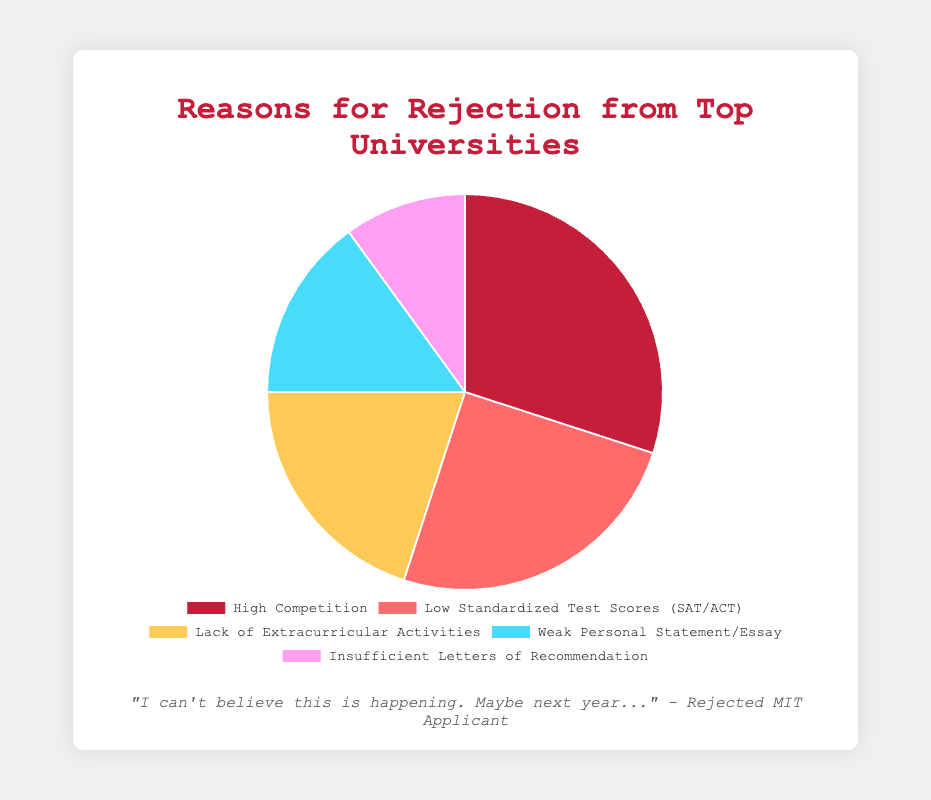What is the most common reason for rejection from top universities? By examining the pie chart, "High Competition" is the segment with the largest percentage.
Answer: High Competition Which reason accounts for the smallest percentage of rejections? The smallest slice of the pie represents "Insufficient Letters of Recommendation" at 10%.
Answer: Insufficient Letters of Recommendation How much larger is the percentage for "Low Standardized Test Scores (SAT/ACT)" compared to "Weak Personal Statement/Essay"? "Low Standardized Test Scores (SAT/ACT)" is 25%, and "Weak Personal Statement/Essay" is 15%. The difference is 10 percentage points.
Answer: 10 percentage points What is the combined percentage of rejections due to "Lack of Extracurricular Activities" and "Weak Personal Statement/Essay"? Summing the percentages for "Lack of Extracurricular Activities" (20%) and "Weak Personal Statement/Essay" (15%) gives 35%.
Answer: 35% Are there more rejections due to "Low Standardized Test Scores (SAT/ACT)" or "Lack of Extracurricular Activities"? The slice for "Low Standardized Test Scores (SAT/ACT)" (25%) is larger than the slice for "Lack of Extracurricular Activities" (20%).
Answer: Low Standardized Test Scores (SAT/ACT) What proportion of rejections is attributed to factors other than "High Competition"? Subtracting the "High Competition" percentage (30%) from 100% gives 70%, indicating the proportion for other factors.
Answer: 70% If you combined the percentages for "Insufficient Letters of Recommendation" and "Weak Personal Statement/Essay", would it exceed the percentage for "High Competition"? "Insufficient Letters of Recommendation" is 10% and "Weak Personal Statement/Essay" is 15%, totaling 25%, which is less than "High Competition" at 30%.
Answer: No Which reason has a lower percentage than "Lack of Extracurricular Activities" but higher than "Insufficient Letters of Recommendation"? The percentages are 20% for "Lack of Extracurricular Activities" and 10% for "Insufficient Letters of Recommendation", so "Weak Personal Statement/Essay" with 15% falls between them.
Answer: Weak Personal Statement/Essay What is the visual color used for the "High Competition" segment? The "High Competition" segment is represented by a red color on the pie chart.
Answer: Red How do the total percentages of "Low Standardized Test Scores (SAT/ACT)" and "Lack of Extracurricular Activities" compare with half of the total pie chart? Adding "Low Standardized Test Scores (SAT/ACT)" (25%) and "Lack of Extracurricular Activities" (20%) gives 45%, which is less than 50%.
Answer: Less 